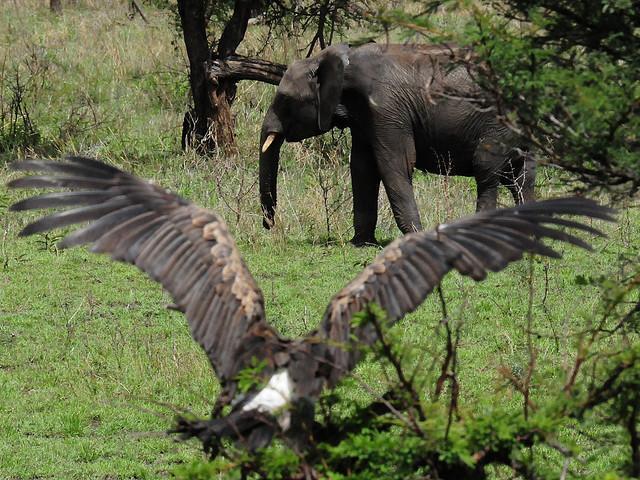How many different animals are there in this photo?
Give a very brief answer. 2. How many people are standing outside the train in the image?
Give a very brief answer. 0. 